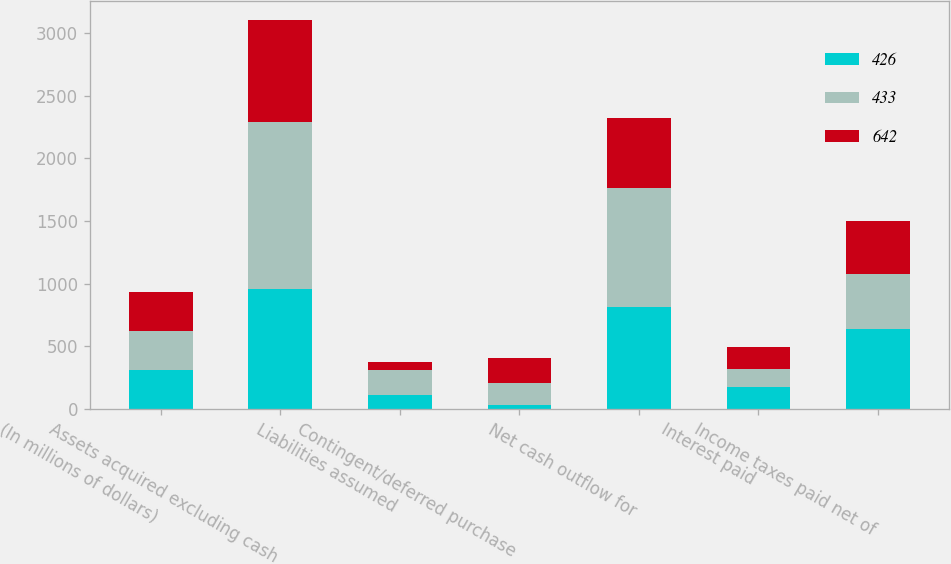Convert chart to OTSL. <chart><loc_0><loc_0><loc_500><loc_500><stacked_bar_chart><ecel><fcel>(In millions of dollars)<fcel>Assets acquired excluding cash<fcel>Liabilities assumed<fcel>Contingent/deferred purchase<fcel>Net cash outflow for<fcel>Interest paid<fcel>Income taxes paid net of<nl><fcel>426<fcel>312.5<fcel>960<fcel>111<fcel>36<fcel>813<fcel>178<fcel>642<nl><fcel>433<fcel>312.5<fcel>1327<fcel>199<fcel>176<fcel>952<fcel>146<fcel>433<nl><fcel>642<fcel>312.5<fcel>815<fcel>64<fcel>197<fcel>554<fcel>172<fcel>426<nl></chart> 